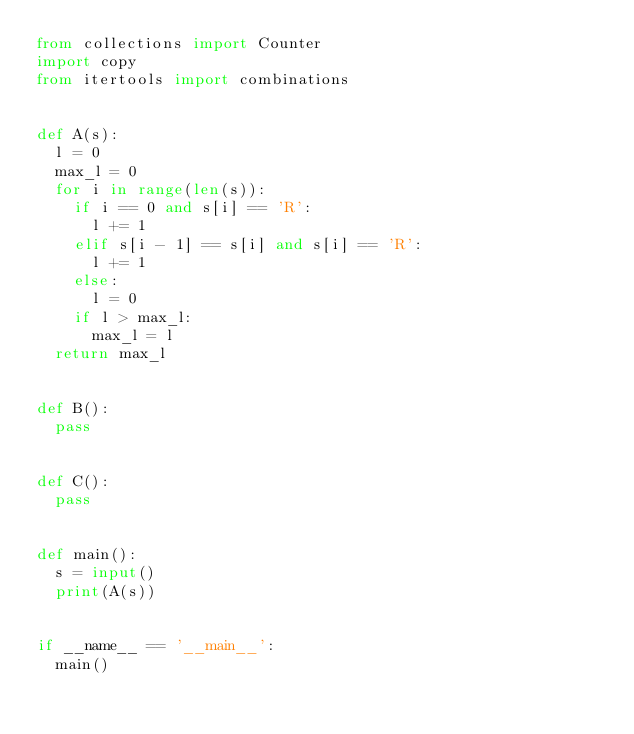Convert code to text. <code><loc_0><loc_0><loc_500><loc_500><_Python_>from collections import Counter
import copy
from itertools import combinations


def A(s):
  l = 0
  max_l = 0
  for i in range(len(s)):
    if i == 0 and s[i] == 'R':
      l += 1
    elif s[i - 1] == s[i] and s[i] == 'R':
      l += 1
    else:
      l = 0
    if l > max_l:
      max_l = l
  return max_l


def B():
  pass


def C():
  pass


def main():
  s = input()
  print(A(s))


if __name__ == '__main__':
  main()
</code> 